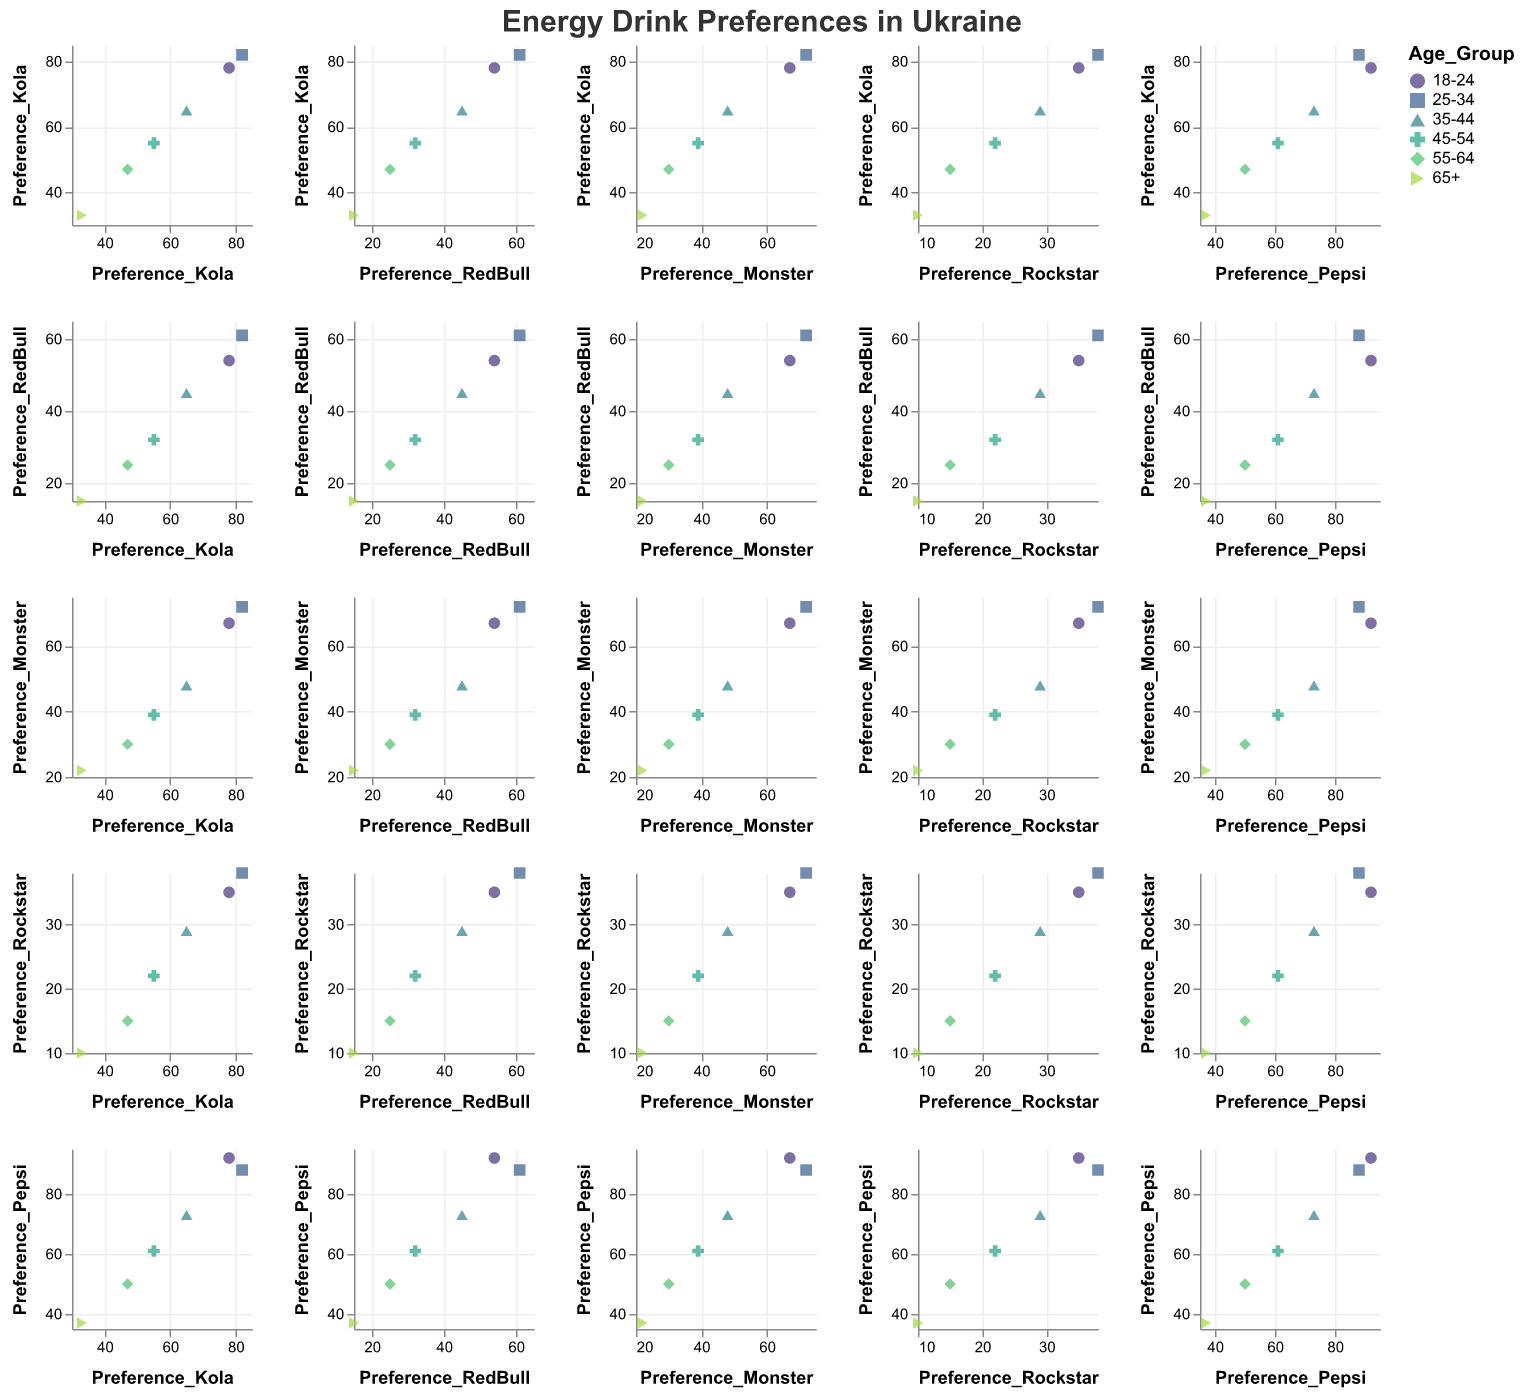What are the beverages being compared in the figure? The figure compares preferences for five beverages: Kola, RedBull, Monster, Rockstar, and Pepsi. These preferences are shown across different age groups in Ukraine.
Answer: Kola, RedBull, Monster, Rockstar, Pepsi Which age group shows the highest preference for Kola? By examining the scatter plot points for Kola, the highest value is seen for the 25-34 age group.
Answer: 25-34 Does the age group "45-54" prefer Monster over Rockstar? The "45-54" age group's preference for Monster is marked at 39 while for Rockstar it is at 22, indicating a higher preference for Monster.
Answer: Yes Which beverage has the highest overall preference score in any age group? The Pepsi preference score for the age group 18-24 is 92, which is the highest overall preference score across all age groups and beverages.
Answer: Pepsi (92) How do the preferences for Kola and Pepsi compare for the 35-44 age group? For the 35-44 age group, the preference scores are 65 for Kola and 73 for Pepsi, indicating a higher preference for Pepsi in this age group.
Answer: Pepsi is preferred more than Kola Is there any age group where Rockstar is preferred over RedBull? By looking at the scatter plot points, we see that in no age group is the preference for Rockstar higher than that for RedBull, as all RedBull scores are greater than those for Rockstar.
Answer: No Which age group has the lowest preference for all beverages combined? Adding the preference scores for each age group:  
18-24: 78+54+67+35+92 = 326  
25-34: 82+61+72+38+88 = 341  
35-44: 65+45+48+29+73 = 260  
45-54: 55+32+39+22+61 = 209  
55-64: 47+25+30+15+50 = 167  
65+: 33+15+22+10+37 = 117  
The age group 65+ has the lowest combined preference score (117).
Answer: 65+ What is the trend in the preference for Monster as the age increases from 18-24 to 65+? As age increases, the preference for Monster decreases according to the values: 18-24 (67), 25-34 (72), 35-44 (48), 45-54 (39), 55-64 (30), and 65+ (22). This indicates a declining trend in preference for Monster as age increases.
Answer: Decreasing trend Is there a significant correlation between the preferences for Kola and Pepsi across all age groups? Observing the scatter plot matrix, if the scatter points for Kola and Pepsi show a pattern (e.g., points aligning in a straight line), it would suggest a correlation. In the matrix, Kola and Pepsi preference points show a slight upward alignment, indicating a positive correlation.
Answer: Yes, there is a slight positive correlation Which age group has the smallest variation in preference among the five beverages? Calculating the range (max-min) for each age group:  
18-24: 78-35 = 43  
25-34: 82-38 = 44  
35-44: 65-29 = 36  
45-54: 55-22 = 33  
55-64: 47-15 = 32  
65+: 33-10 = 23  
The smallest variation in preference is in the 65+ age group with a range of 23.
Answer: 65+ 